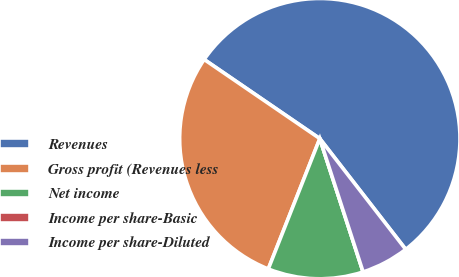<chart> <loc_0><loc_0><loc_500><loc_500><pie_chart><fcel>Revenues<fcel>Gross profit (Revenues less<fcel>Net income<fcel>Income per share-Basic<fcel>Income per share-Diluted<nl><fcel>54.95%<fcel>28.56%<fcel>10.99%<fcel>0.0%<fcel>5.5%<nl></chart> 